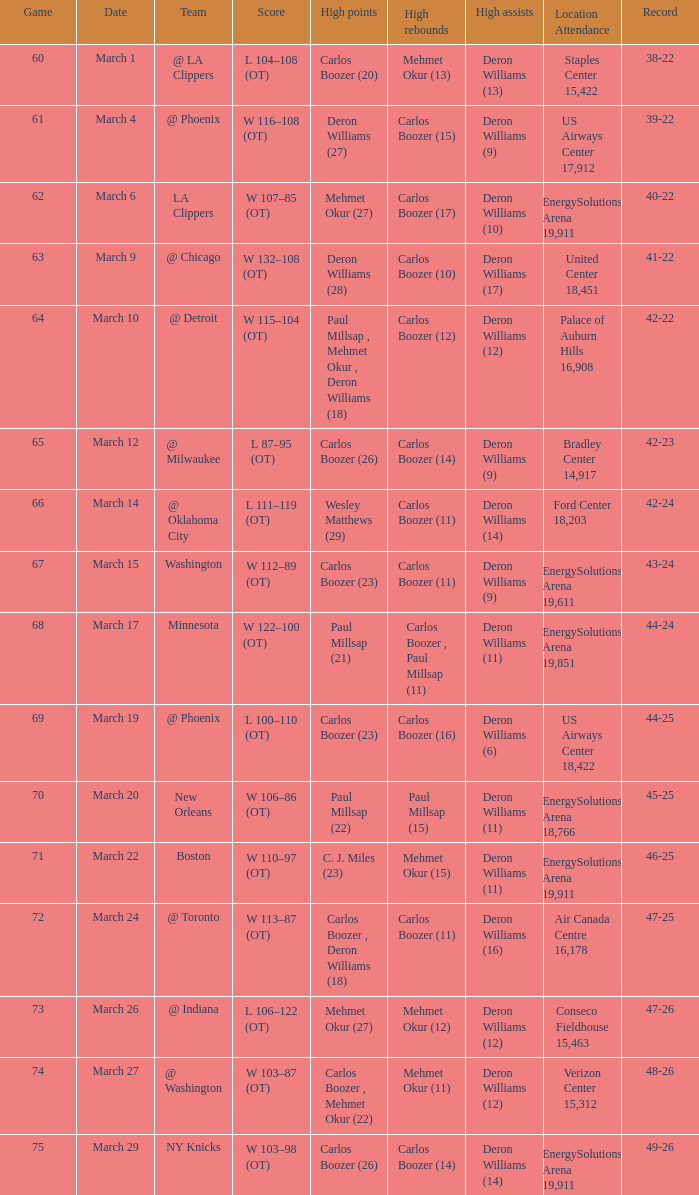How many different players did the most high assists on the March 4 game? 1.0. 